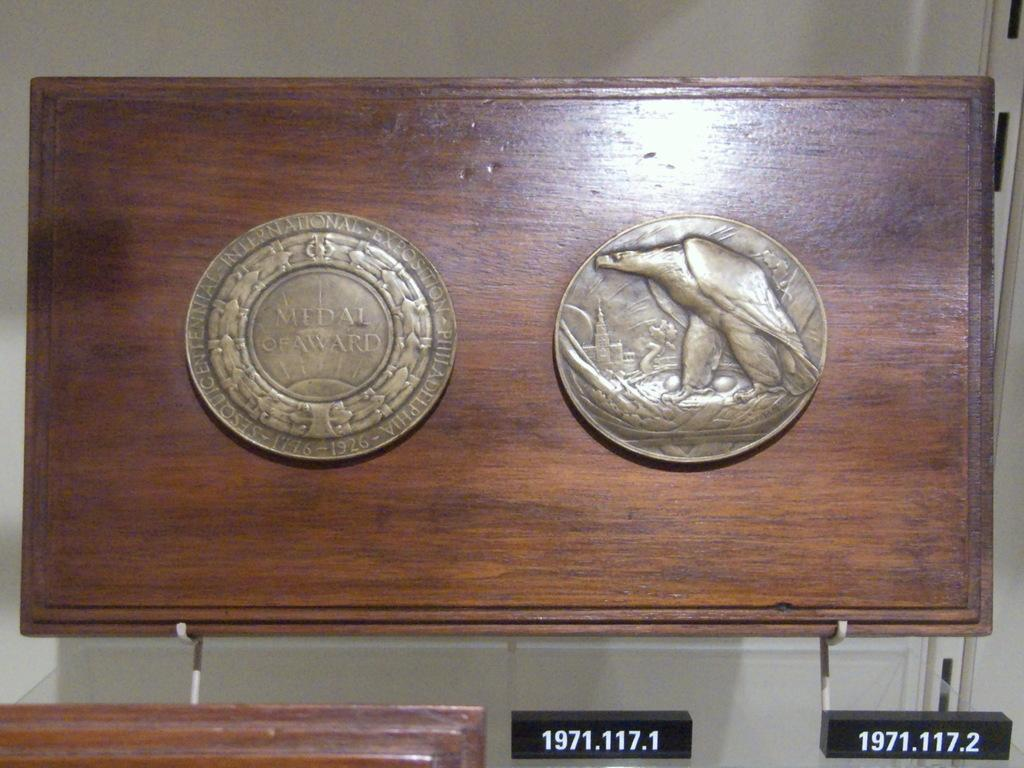<image>
Present a compact description of the photo's key features. two round medals one of which has Medal of Award written on it 